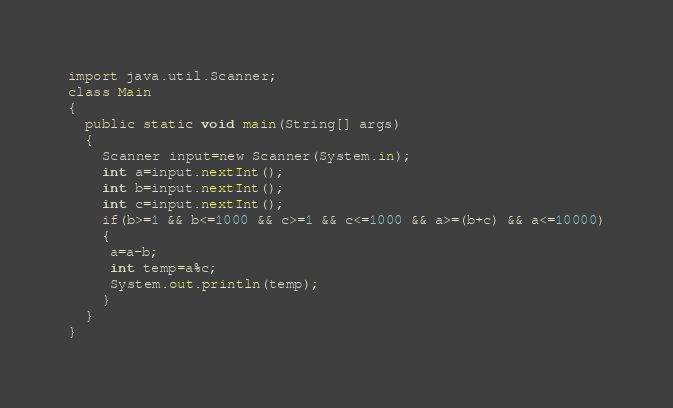<code> <loc_0><loc_0><loc_500><loc_500><_Java_>import java.util.Scanner;
class Main 
{
  public static void main(String[] args) 
  {
    Scanner input=new Scanner(System.in);
    int a=input.nextInt();
    int b=input.nextInt();
    int c=input.nextInt();
    if(b>=1 && b<=1000 && c>=1 && c<=1000 && a>=(b+c) && a<=10000)
    {
     a=a-b;
     int temp=a%c;
     System.out.println(temp);
    }
  }
}</code> 